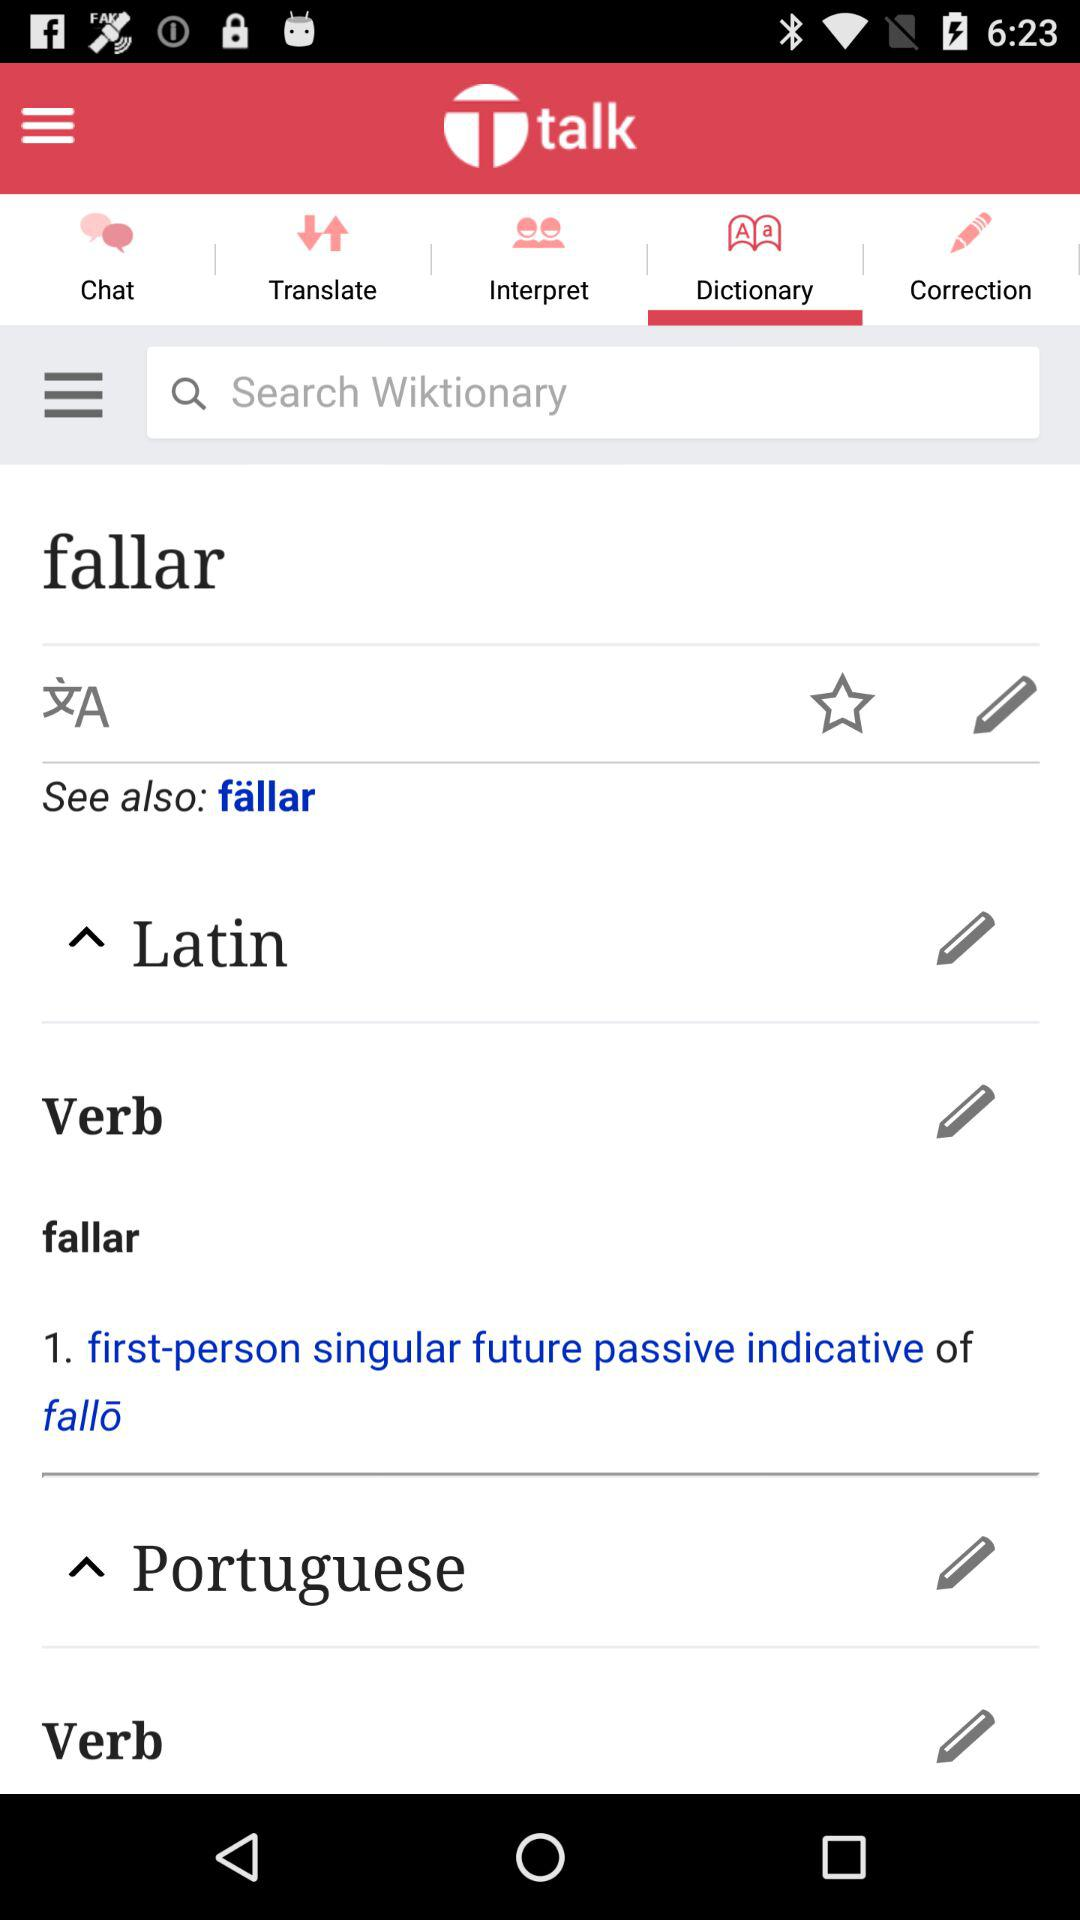What is the name of the application? The name of the application is "Ttalk". 